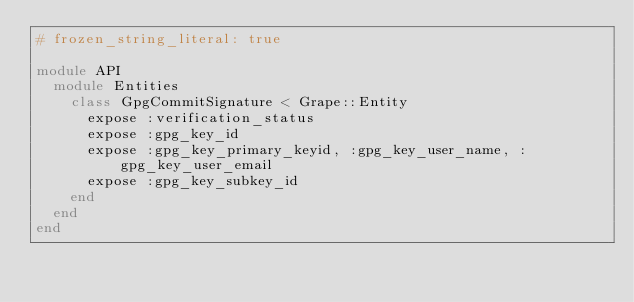<code> <loc_0><loc_0><loc_500><loc_500><_Ruby_># frozen_string_literal: true

module API
  module Entities
    class GpgCommitSignature < Grape::Entity
      expose :verification_status
      expose :gpg_key_id
      expose :gpg_key_primary_keyid, :gpg_key_user_name, :gpg_key_user_email
      expose :gpg_key_subkey_id
    end
  end
end
</code> 